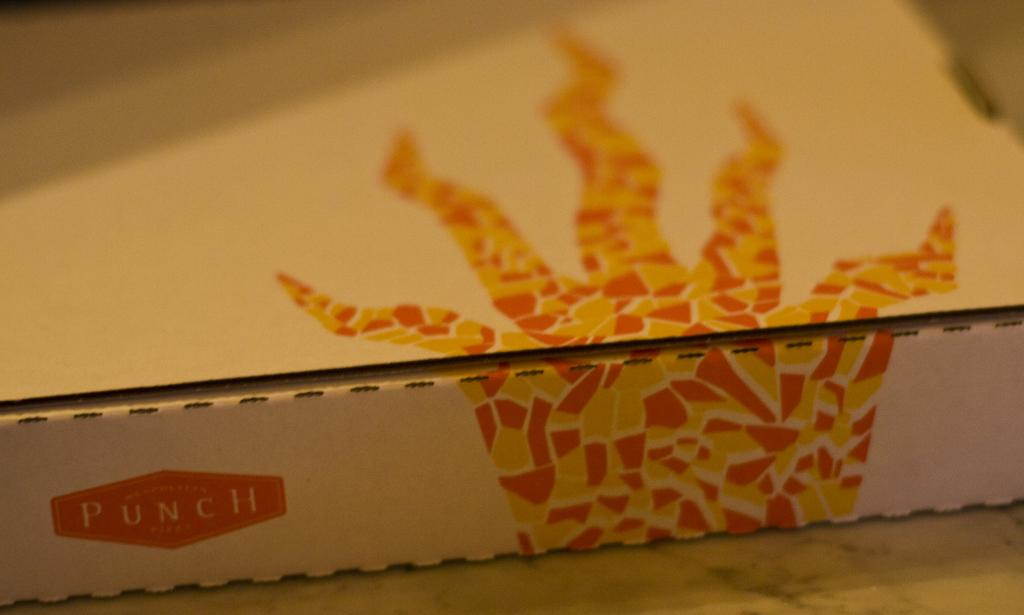<image>
Describe the image concisely. A white cardboard box with a yellow and orange graphic along with the word Punch on the side. 